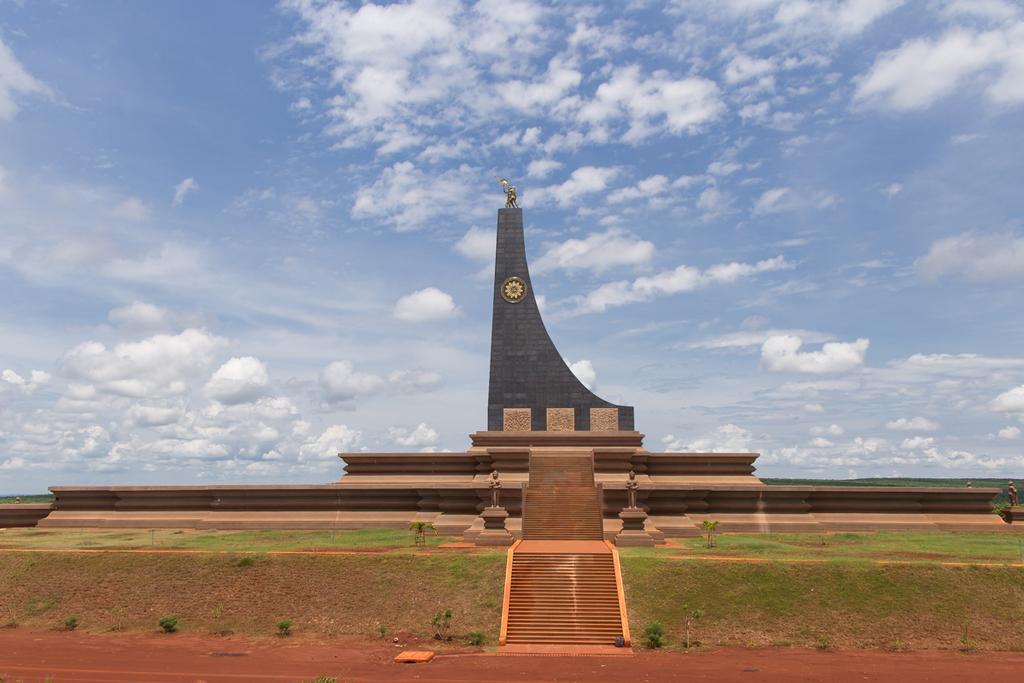How would you summarize this image in a sentence or two? In this image there is one building and there are some stairs, at the bottom there is sand and grass and some plants. At the top of the image there is sky. 